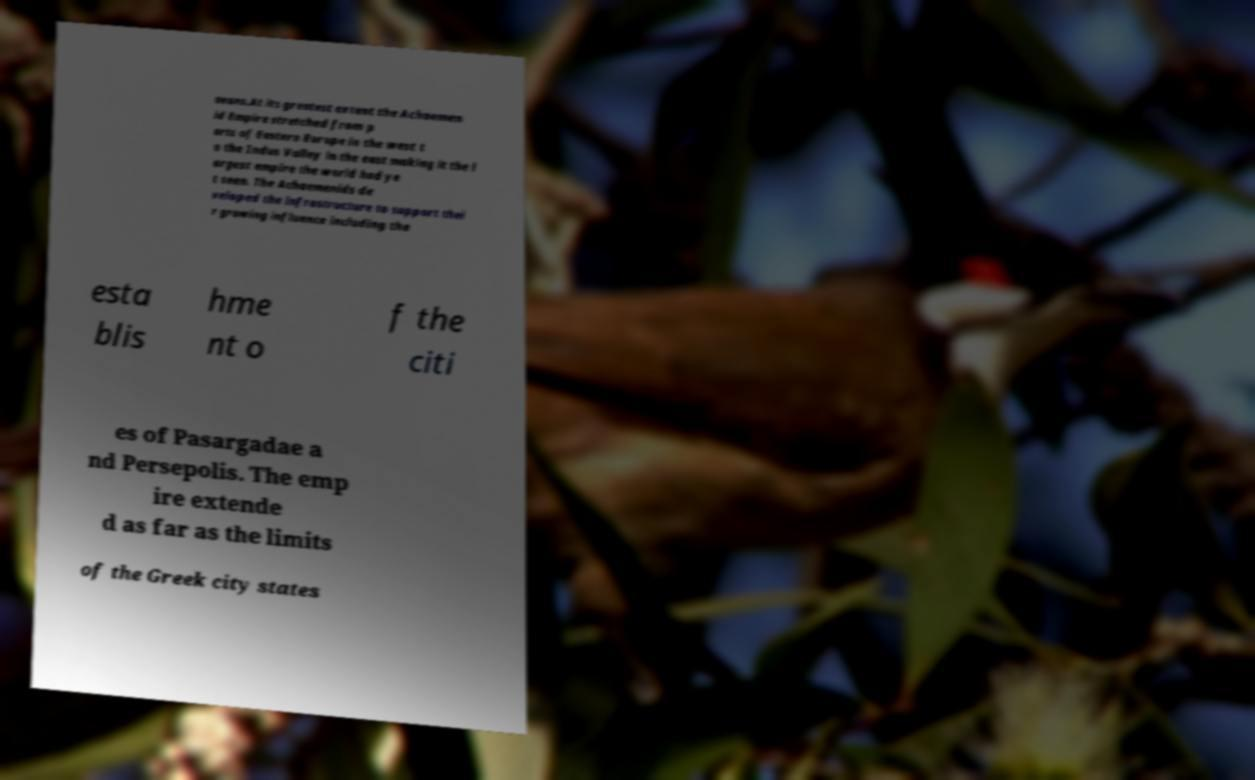Could you assist in decoding the text presented in this image and type it out clearly? aeans.At its greatest extent the Achaemen id Empire stretched from p arts of Eastern Europe in the west t o the Indus Valley in the east making it the l argest empire the world had ye t seen. The Achaemenids de veloped the infrastructure to support thei r growing influence including the esta blis hme nt o f the citi es of Pasargadae a nd Persepolis. The emp ire extende d as far as the limits of the Greek city states 